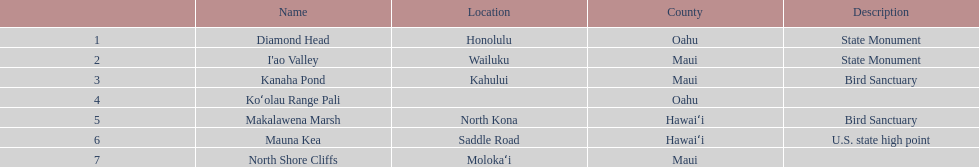What is the number of bird sanctuary landmarks? 2. 